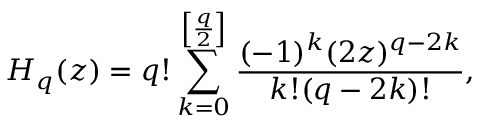Convert formula to latex. <formula><loc_0><loc_0><loc_500><loc_500>H _ { q } ( z ) = q ! \sum _ { k = 0 } ^ { \left [ \frac { q } { 2 } \right ] } \frac { ( - 1 ) ^ { k } ( 2 z ) ^ { q - 2 k } } { k ! ( q - 2 k ) ! } ,</formula> 